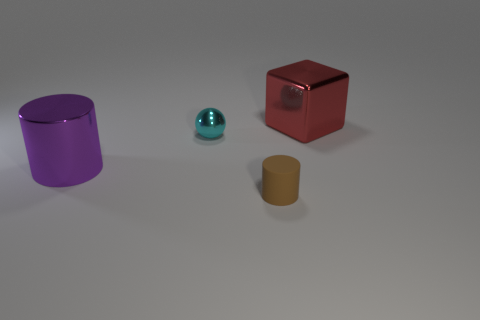Add 1 metallic cubes. How many objects exist? 5 Subtract 1 spheres. How many spheres are left? 0 Subtract all purple cylinders. How many cylinders are left? 1 Add 4 purple cylinders. How many purple cylinders are left? 5 Add 1 balls. How many balls exist? 2 Subtract 0 cyan cylinders. How many objects are left? 4 Subtract all blocks. How many objects are left? 3 Subtract all purple blocks. Subtract all gray spheres. How many blocks are left? 1 Subtract all blue cubes. How many purple cylinders are left? 1 Subtract all tiny objects. Subtract all purple metal things. How many objects are left? 1 